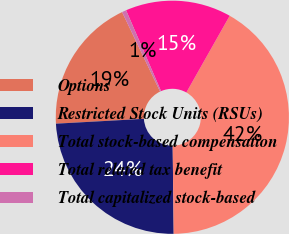<chart> <loc_0><loc_0><loc_500><loc_500><pie_chart><fcel>Options<fcel>Restricted Stock Units (RSUs)<fcel>Total stock-based compensation<fcel>Total related tax benefit<fcel>Total capitalized stock-based<nl><fcel>18.78%<fcel>24.31%<fcel>41.63%<fcel>14.68%<fcel>0.6%<nl></chart> 